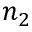<formula> <loc_0><loc_0><loc_500><loc_500>n _ { 2 }</formula> 